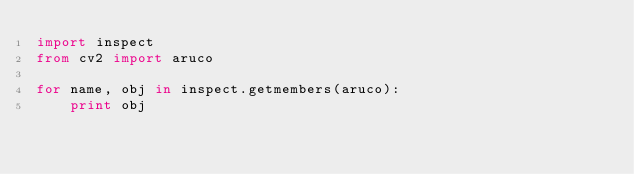Convert code to text. <code><loc_0><loc_0><loc_500><loc_500><_Python_>import inspect
from cv2 import aruco

for name, obj in inspect.getmembers(aruco):
    print obj
</code> 